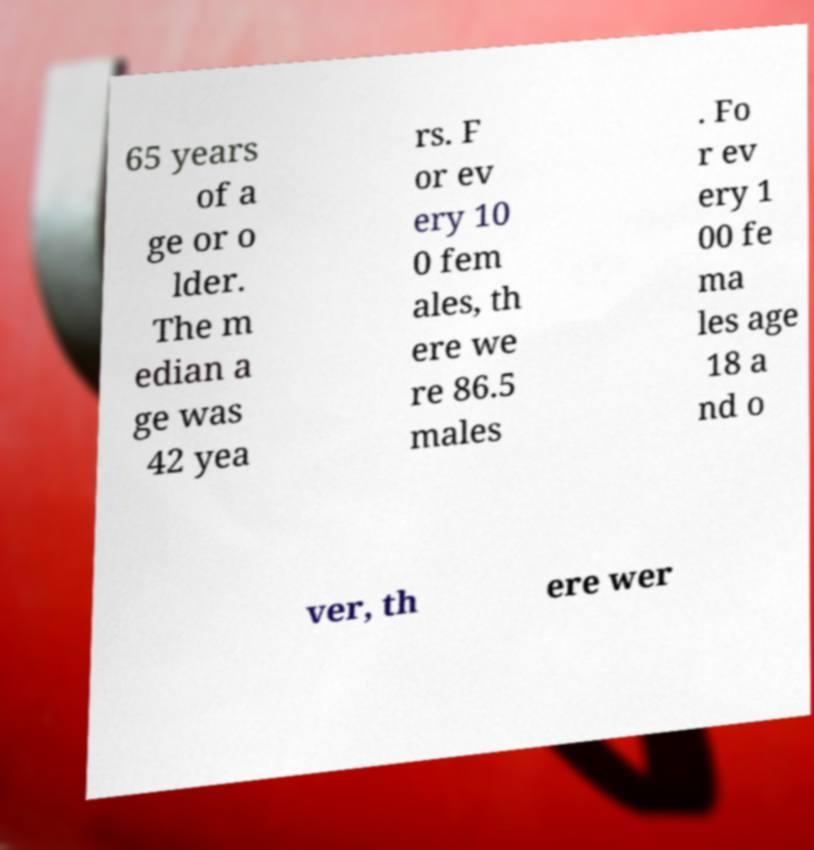Please read and relay the text visible in this image. What does it say? 65 years of a ge or o lder. The m edian a ge was 42 yea rs. F or ev ery 10 0 fem ales, th ere we re 86.5 males . Fo r ev ery 1 00 fe ma les age 18 a nd o ver, th ere wer 